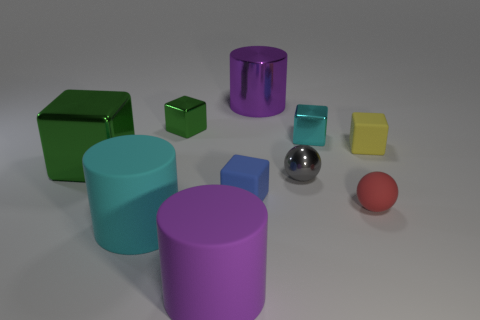What color is the big metal thing on the left side of the purple cylinder that is to the left of the purple metal thing?
Ensure brevity in your answer.  Green. What material is the green block that is the same size as the purple metal object?
Give a very brief answer. Metal. How many matte objects are green spheres or cyan cylinders?
Your answer should be compact. 1. There is a metallic thing that is both in front of the tiny green object and behind the small yellow rubber block; what color is it?
Offer a terse response. Cyan. There is a tiny yellow cube; how many small blocks are to the left of it?
Provide a succinct answer. 3. What material is the tiny cyan cube?
Give a very brief answer. Metal. There is a large cylinder right of the blue thing in front of the cyan thing right of the large metal cylinder; what color is it?
Give a very brief answer. Purple. What number of purple cylinders are the same size as the purple metallic object?
Provide a short and direct response. 1. There is a cylinder behind the gray ball; what is its color?
Keep it short and to the point. Purple. What number of other objects are the same size as the gray metallic object?
Ensure brevity in your answer.  5. 